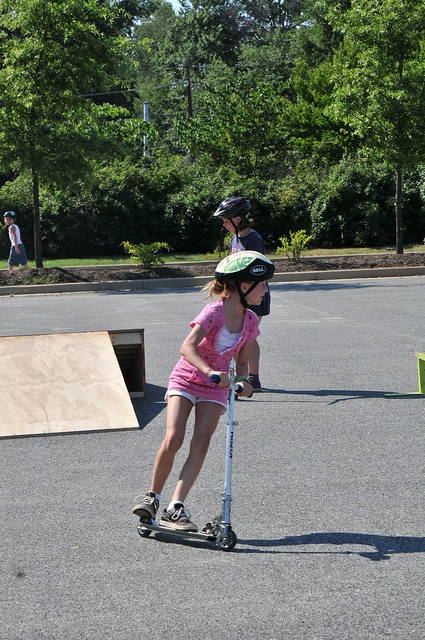Describe the objects in this image and their specific colors. I can see people in khaki, gray, black, purple, and maroon tones, people in khaki, black, gray, darkgray, and brown tones, and people in khaki, black, gray, navy, and darkgray tones in this image. 